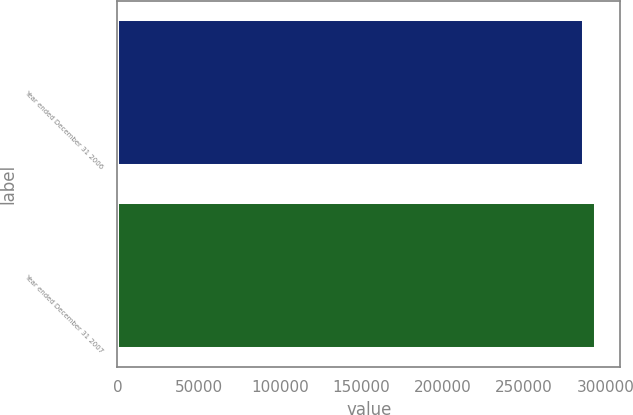Convert chart to OTSL. <chart><loc_0><loc_0><loc_500><loc_500><bar_chart><fcel>Year ended December 31 2006<fcel>Year ended December 31 2007<nl><fcel>286528<fcel>294483<nl></chart> 